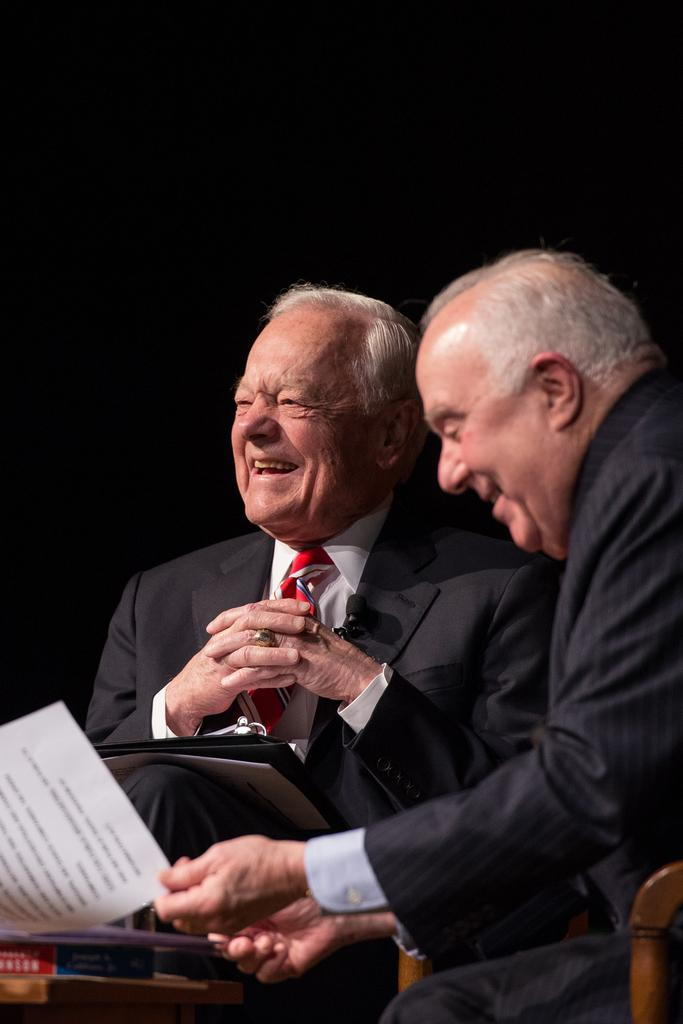How many people are in the image? There are two persons in the image. What are the positions of the persons in the image? Both persons are sitting in chairs. What is one person doing with a file? One person has a file in their lap. What is the other person doing with papers? The other person is taking papers from the table. What can be observed about the background of the image? The background of the image is dark. What type of amusement can be seen in the image? There is no amusement present in the image; it features two people sitting in chairs and interacting with files and papers. What is the chance of winning a prize in the image? There is no mention of a prize or any game of chance in the image. 